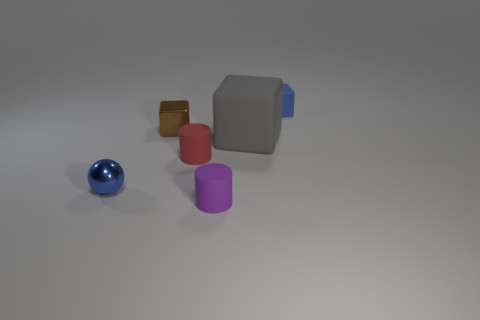There is a object that is the same color as the sphere; what is its size?
Offer a very short reply. Small. What material is the brown object?
Offer a terse response. Metal. What is the color of the other metallic thing that is the same size as the brown metallic object?
Offer a very short reply. Blue. There is a object that is the same color as the small shiny sphere; what is its shape?
Your response must be concise. Cube. Is the blue metallic object the same shape as the tiny brown thing?
Your answer should be compact. No. What is the tiny thing that is on the right side of the brown metallic object and to the left of the small purple rubber cylinder made of?
Make the answer very short. Rubber. What is the size of the red cylinder?
Provide a succinct answer. Small. There is another small object that is the same shape as the brown metal thing; what color is it?
Provide a succinct answer. Blue. Are there any other things that have the same color as the large block?
Offer a very short reply. No. Do the matte object to the left of the purple matte thing and the brown cube that is behind the small purple cylinder have the same size?
Make the answer very short. Yes. 